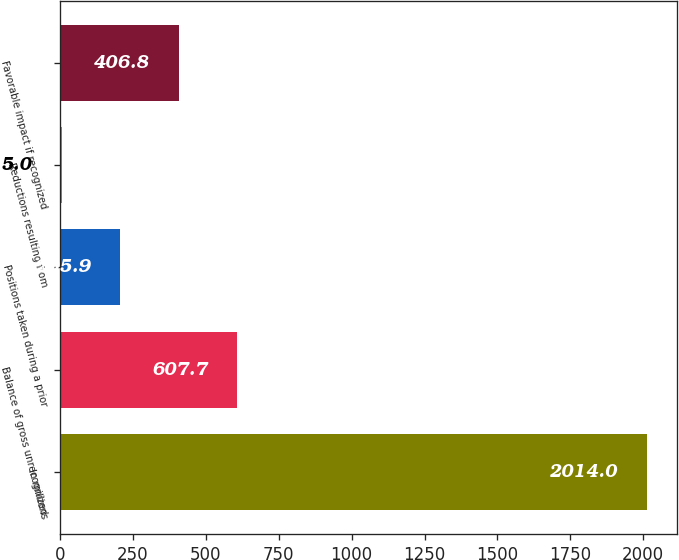Convert chart. <chart><loc_0><loc_0><loc_500><loc_500><bar_chart><fcel>In millions<fcel>Balance of gross unrecognized<fcel>Positions taken during a prior<fcel>Reductions resulting from<fcel>Favorable impact if recognized<nl><fcel>2014<fcel>607.7<fcel>205.9<fcel>5<fcel>406.8<nl></chart> 